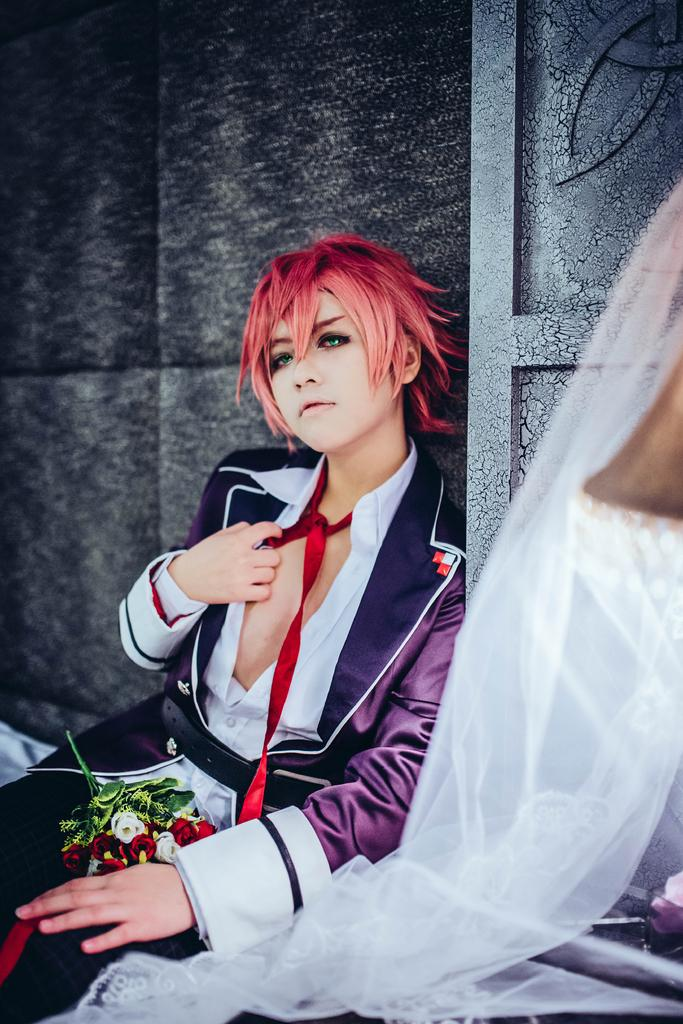What is the woman in the image doing? The woman is sitting in the image. What type of flowers can be seen in the image? There are roses visible in the image. What is in the background of the image? There is a wall in the background of the image. What can be seen on the right side of the image? There is a white color net on the right side of the image. Can you tell me how many kittens are playing with a mitten in the image? There are no kittens or mittens present in the image. What type of impulse is causing the woman to sit in the image? The image does not provide information about the woman's motivation or impulse for sitting. 